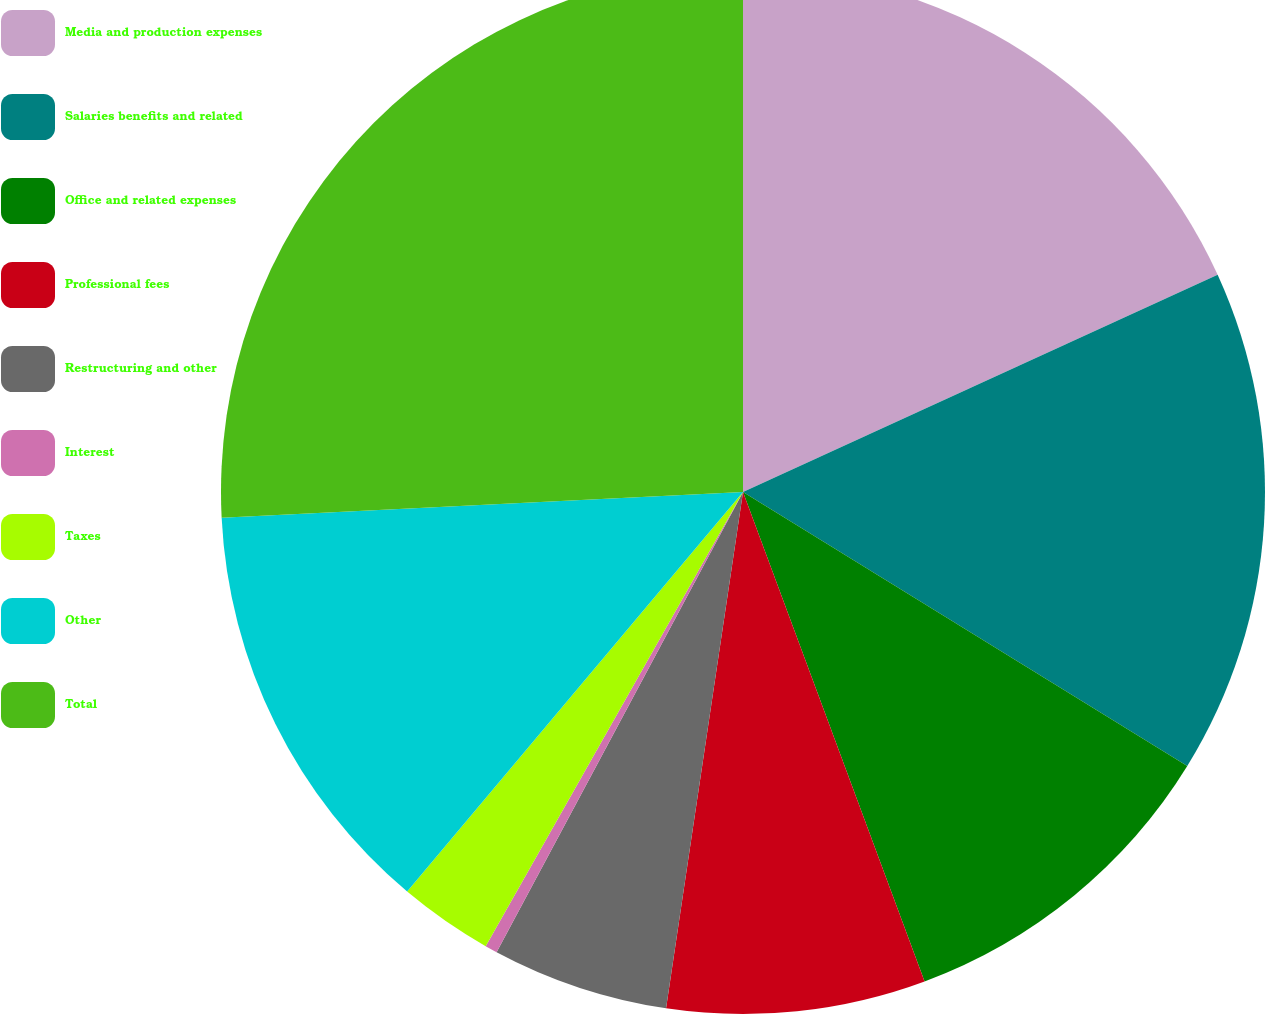Convert chart to OTSL. <chart><loc_0><loc_0><loc_500><loc_500><pie_chart><fcel>Media and production expenses<fcel>Salaries benefits and related<fcel>Office and related expenses<fcel>Professional fees<fcel>Restructuring and other<fcel>Interest<fcel>Taxes<fcel>Other<fcel>Total<nl><fcel>18.17%<fcel>15.63%<fcel>10.55%<fcel>8.01%<fcel>5.47%<fcel>0.38%<fcel>2.92%<fcel>13.09%<fcel>25.79%<nl></chart> 